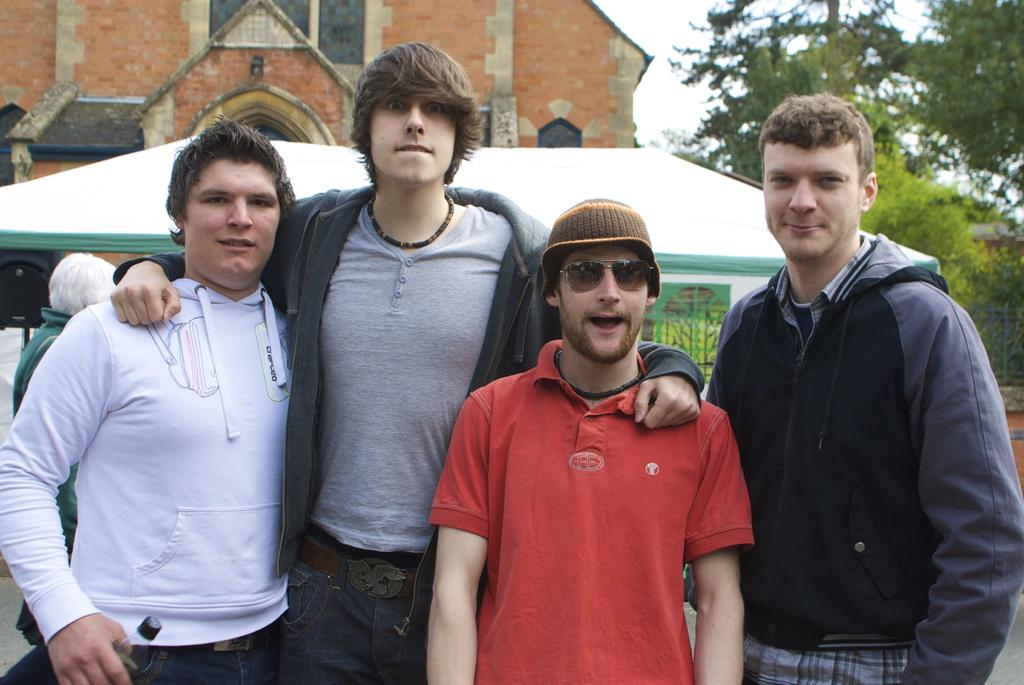What is happening in the image? There are people standing in the image. What can be seen in the background of the image? There is a building and green trees in the background of the image. What is visible at the top of the image? The sky is visible at the top of the image. What type of cable can be seen connecting the people in the image? There is no cable present in the image; it only shows people standing. 